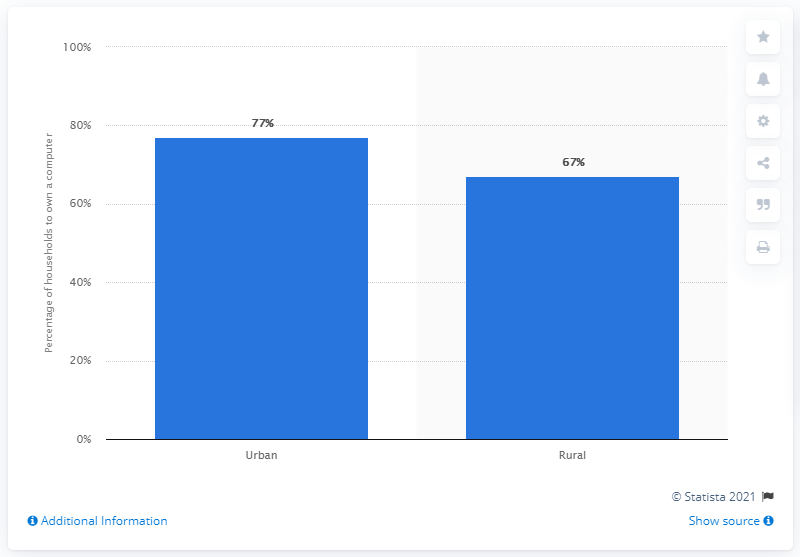Outline some significant characteristics in this image. The location with the highest computer ownership is urban. The ratio of urban to rural populations is 1.149253731..., which translates to a significant difference in population distribution between urban and rural areas. 